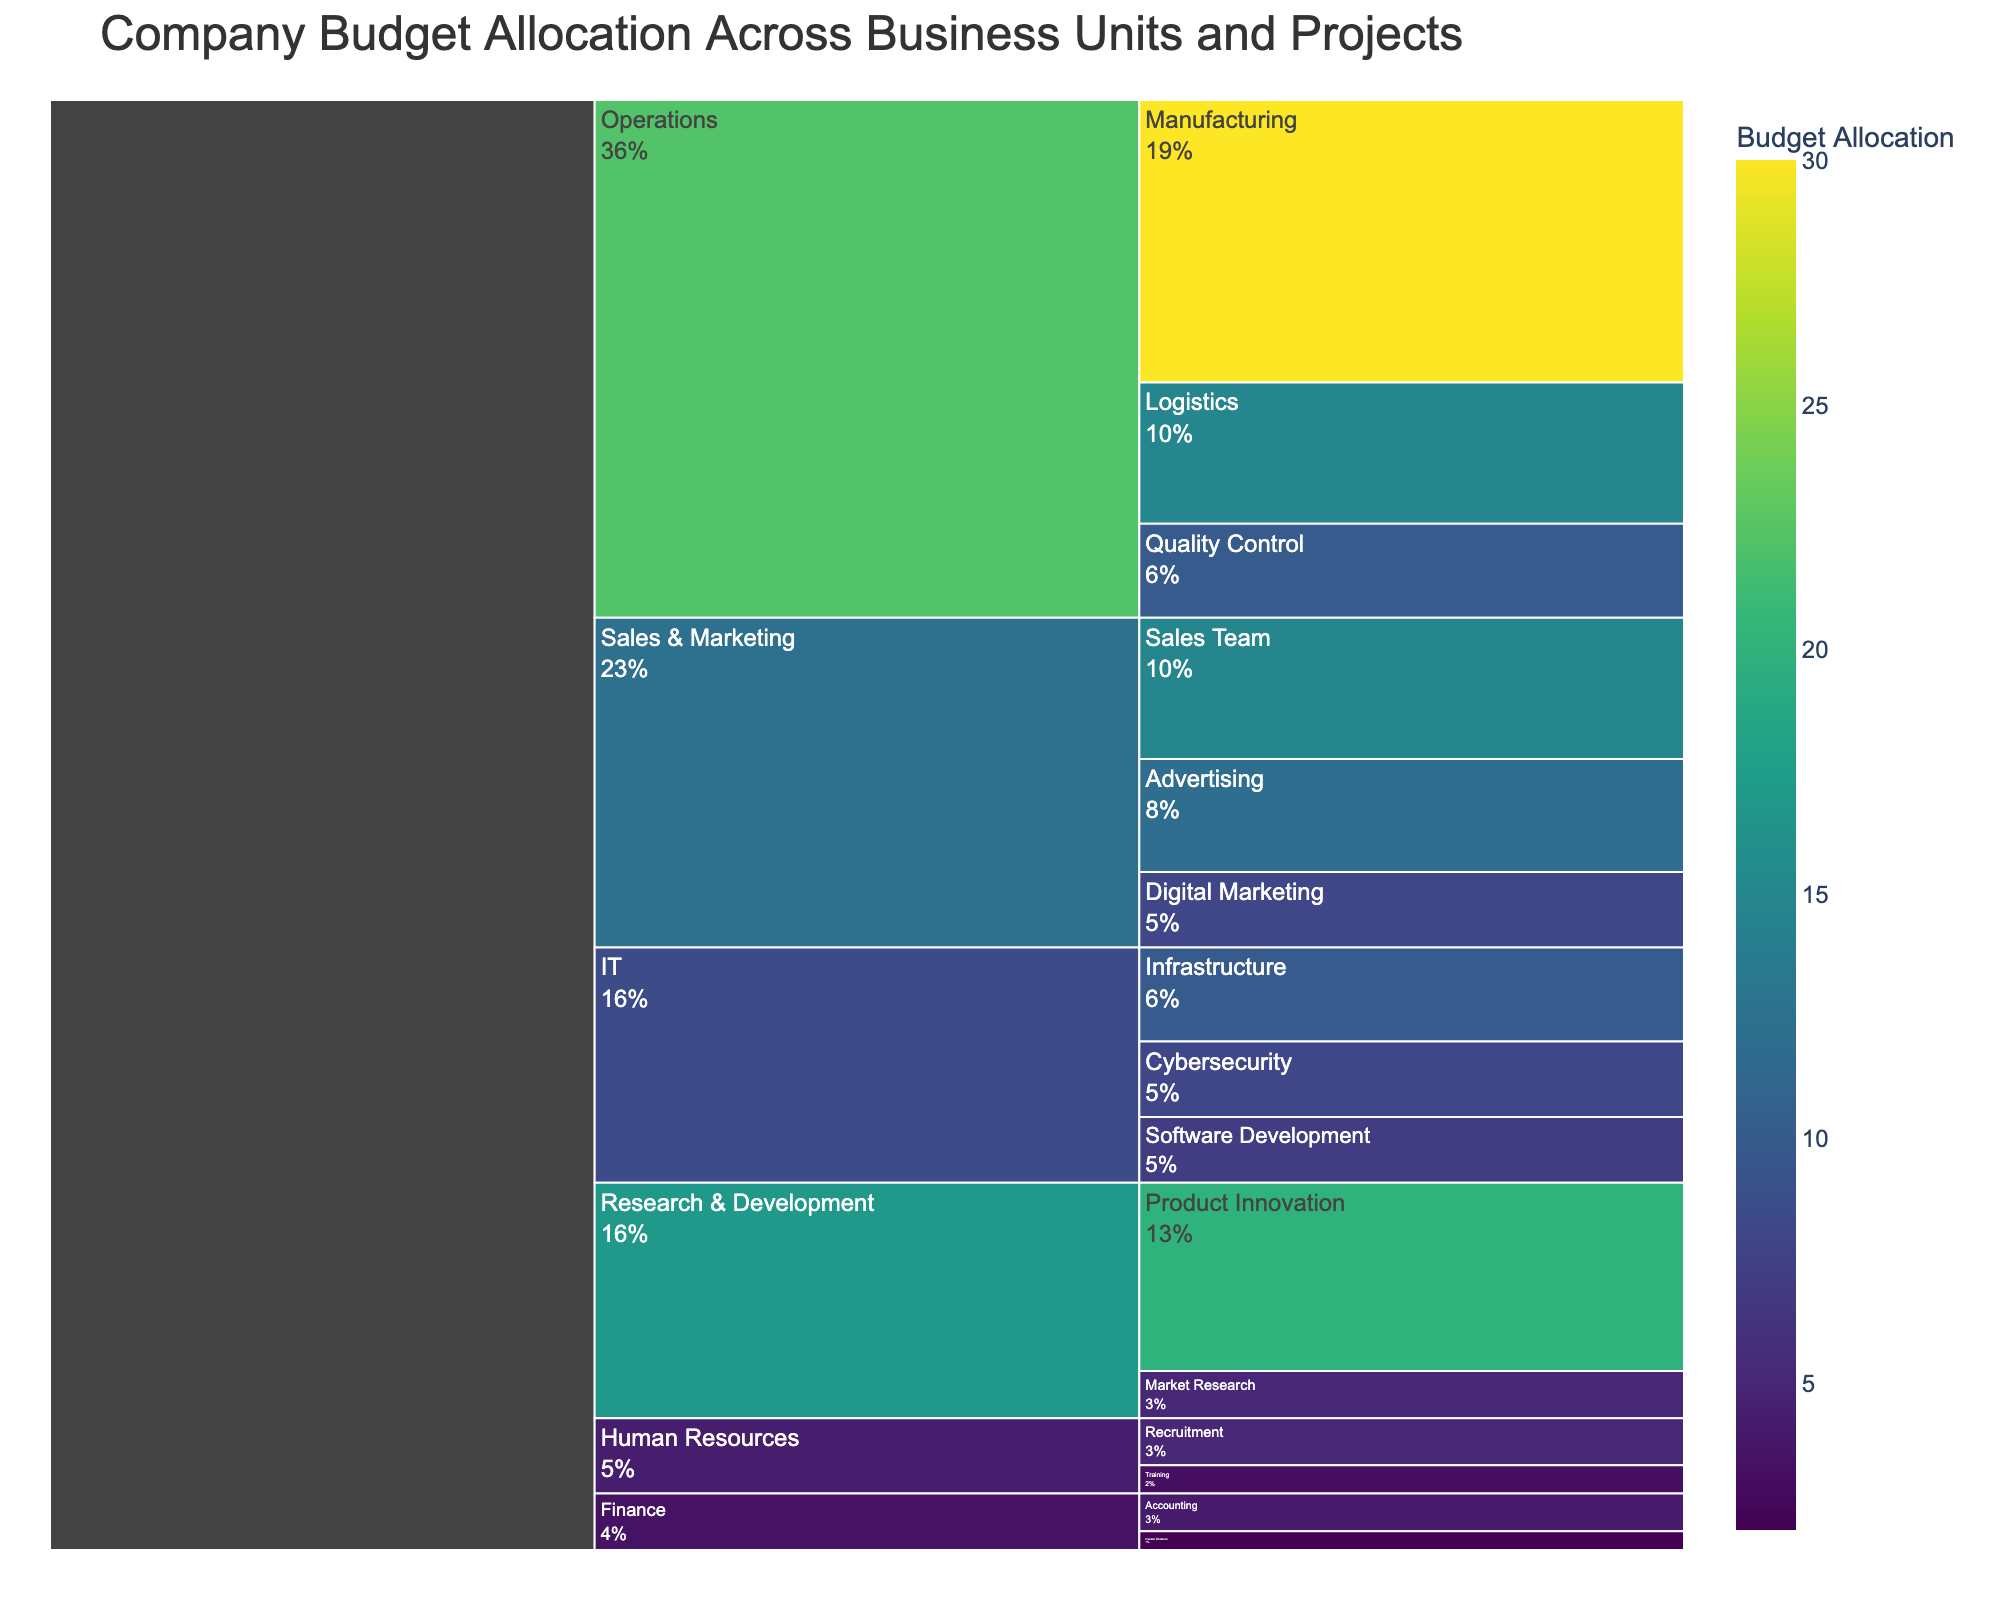What is the title of the icicle chart? The title is located at the top of the chart, usually in larger, bold font. From the data provided, the title is 'Company Budget Allocation Across Business Units and Projects'.
Answer: Company Budget Allocation Across Business Units and Projects Which subcategory in Operations has the highest budget allocation? The subcategories in Operations are Manufacturing, Logistics, and Quality Control. By comparing their budget values (30, 15, 10 respectively), Manufacturing has the highest value.
Answer: Manufacturing What is the total budget allocated to Sales & Marketing? Summing up the budget values for Advertising (12), Digital Marketing (8), and Sales Team (15), we get 12 + 8 + 15 = 35 million.
Answer: 35 million Which business unit has the smallest budget allocation? By evaluating the total values in each category, Finance has the smallest total allocation (4 for Accounting and 2 for Investor Relations, totaling 6).
Answer: Finance How does the budget for Product Innovation compare to the budget for Software Development? Product Innovation has a budget of 20 and Software Development has a budget of 7. Comparing these, Product Innovation has a significantly higher budget.
Answer: Product Innovation What percentage of the entire budget is allocated to Digital Marketing? The total budget can be calculated by summing all individual values (30 + 15 + 10 + 12 + 8 + 15 + 20 + 5 + 10 + 8 + 7 + 5 + 3 + 4 + 2 = 154). The percentage for Digital Marketing is then (8/154) * 100 = approximately 5.2%.
Answer: 5.2% What is the combined budget allocation for Research & Development? Adding the budget values for Product Innovation (20) and Market Research (5), we obtain 20 + 5 = 25 million.
Answer: 25 million What percentage of Operations' budget goes to Quality Control? The total budget for Operations is the sum of its subcategories: Manufacturing (30), Logistics (15), and Quality Control (10), which is 30 + 15 + 10 = 55. The percentage for Quality Control is (10/55) * 100 = approximately 18.2%.
Answer: 18.2% Which subcategory within IT has the lowest budget allocation? The subcategories in IT are Infrastructure (10), Cybersecurity (8), and Software Development (7). Software Development has the lowest budget.
Answer: Software Development How much more budget is allocated to Manufacturing compared to the entire Human Resources unit? Manufacturing has a budget of 30, while Human Resources has Recruitment (5) and Training (3), totaling 8. The difference is 30 - 8 = 22 million.
Answer: 22 million 